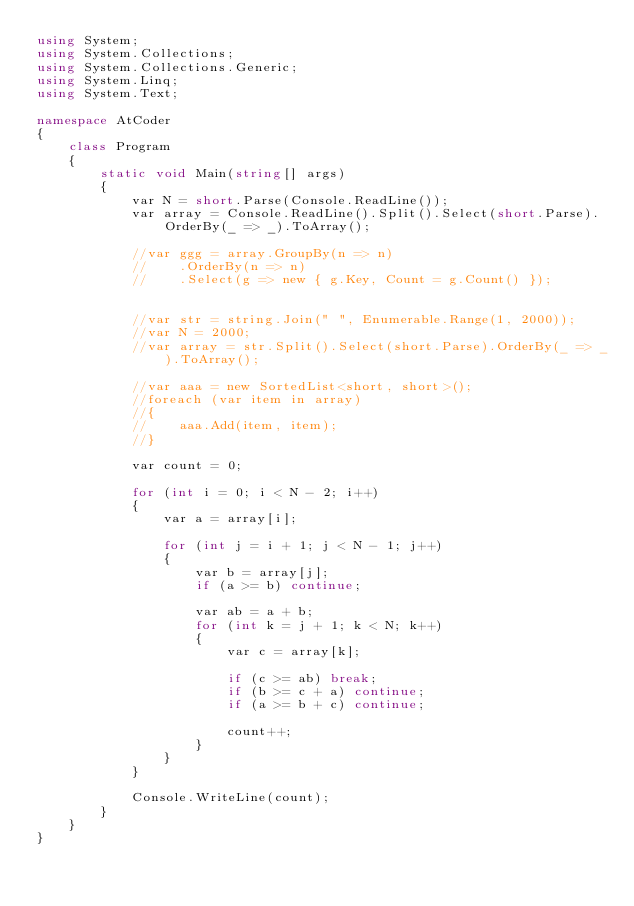<code> <loc_0><loc_0><loc_500><loc_500><_C#_>using System;
using System.Collections;
using System.Collections.Generic;
using System.Linq;
using System.Text;

namespace AtCoder
{
    class Program
    {
        static void Main(string[] args)
        {
            var N = short.Parse(Console.ReadLine());
            var array = Console.ReadLine().Split().Select(short.Parse).OrderBy(_ => _).ToArray();

            //var ggg = array.GroupBy(n => n)
            //    .OrderBy(n => n)
            //    .Select(g => new { g.Key, Count = g.Count() });


            //var str = string.Join(" ", Enumerable.Range(1, 2000));
            //var N = 2000;
            //var array = str.Split().Select(short.Parse).OrderBy(_ => _).ToArray();

            //var aaa = new SortedList<short, short>();
            //foreach (var item in array)
            //{
            //    aaa.Add(item, item);
            //}

            var count = 0;

            for (int i = 0; i < N - 2; i++)
            {
                var a = array[i];

                for (int j = i + 1; j < N - 1; j++)
                {
                    var b = array[j];
                    if (a >= b) continue;

                    var ab = a + b;
                    for (int k = j + 1; k < N; k++)
                    {
                        var c = array[k];

                        if (c >= ab) break;
                        if (b >= c + a) continue;
                        if (a >= b + c) continue;

                        count++;
                    }
                }
            }

            Console.WriteLine(count);
        }
    }
}
</code> 